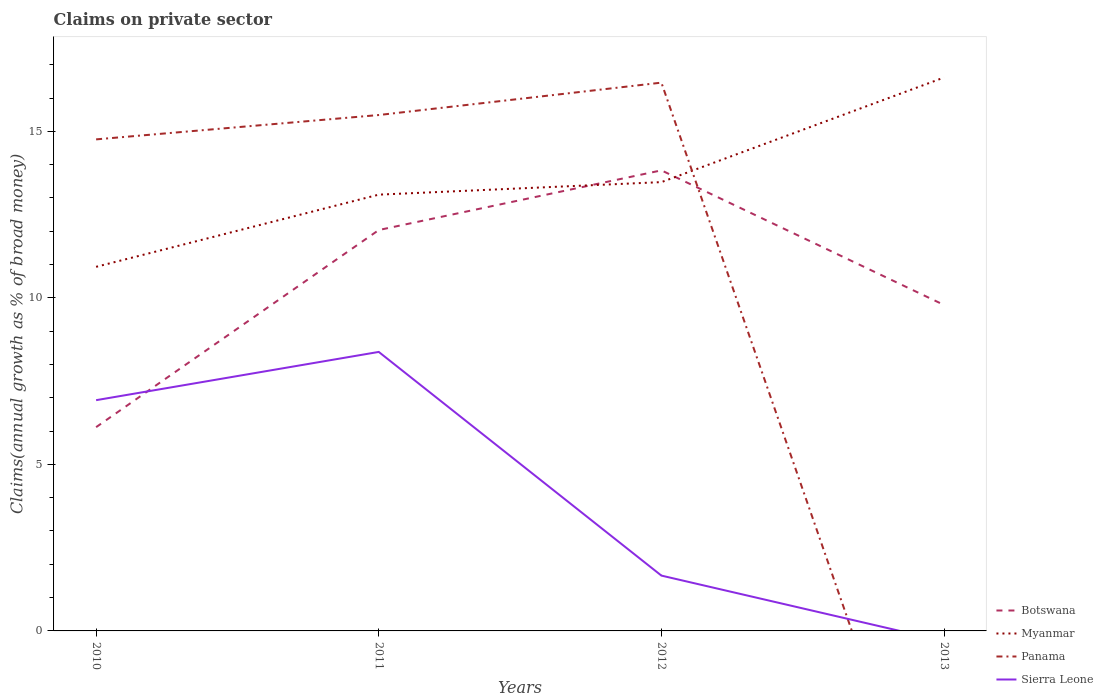How many different coloured lines are there?
Your answer should be compact. 4. Across all years, what is the maximum percentage of broad money claimed on private sector in Sierra Leone?
Provide a short and direct response. 0. What is the total percentage of broad money claimed on private sector in Botswana in the graph?
Provide a succinct answer. 4.04. What is the difference between the highest and the second highest percentage of broad money claimed on private sector in Sierra Leone?
Your answer should be compact. 8.38. Are the values on the major ticks of Y-axis written in scientific E-notation?
Your response must be concise. No. Where does the legend appear in the graph?
Give a very brief answer. Bottom right. How many legend labels are there?
Your answer should be very brief. 4. How are the legend labels stacked?
Offer a terse response. Vertical. What is the title of the graph?
Offer a terse response. Claims on private sector. What is the label or title of the X-axis?
Provide a short and direct response. Years. What is the label or title of the Y-axis?
Your response must be concise. Claims(annual growth as % of broad money). What is the Claims(annual growth as % of broad money) of Botswana in 2010?
Offer a very short reply. 6.12. What is the Claims(annual growth as % of broad money) of Myanmar in 2010?
Make the answer very short. 10.93. What is the Claims(annual growth as % of broad money) in Panama in 2010?
Your answer should be very brief. 14.76. What is the Claims(annual growth as % of broad money) of Sierra Leone in 2010?
Provide a succinct answer. 6.93. What is the Claims(annual growth as % of broad money) in Botswana in 2011?
Give a very brief answer. 12.04. What is the Claims(annual growth as % of broad money) in Myanmar in 2011?
Offer a very short reply. 13.1. What is the Claims(annual growth as % of broad money) in Panama in 2011?
Give a very brief answer. 15.49. What is the Claims(annual growth as % of broad money) in Sierra Leone in 2011?
Offer a very short reply. 8.38. What is the Claims(annual growth as % of broad money) of Botswana in 2012?
Your answer should be compact. 13.83. What is the Claims(annual growth as % of broad money) of Myanmar in 2012?
Provide a succinct answer. 13.47. What is the Claims(annual growth as % of broad money) in Panama in 2012?
Offer a very short reply. 16.46. What is the Claims(annual growth as % of broad money) of Sierra Leone in 2012?
Offer a very short reply. 1.66. What is the Claims(annual growth as % of broad money) in Botswana in 2013?
Make the answer very short. 9.79. What is the Claims(annual growth as % of broad money) in Myanmar in 2013?
Offer a terse response. 16.62. What is the Claims(annual growth as % of broad money) in Panama in 2013?
Provide a succinct answer. 0. What is the Claims(annual growth as % of broad money) in Sierra Leone in 2013?
Your answer should be very brief. 0. Across all years, what is the maximum Claims(annual growth as % of broad money) of Botswana?
Ensure brevity in your answer.  13.83. Across all years, what is the maximum Claims(annual growth as % of broad money) in Myanmar?
Provide a short and direct response. 16.62. Across all years, what is the maximum Claims(annual growth as % of broad money) of Panama?
Offer a very short reply. 16.46. Across all years, what is the maximum Claims(annual growth as % of broad money) in Sierra Leone?
Offer a very short reply. 8.38. Across all years, what is the minimum Claims(annual growth as % of broad money) of Botswana?
Your answer should be very brief. 6.12. Across all years, what is the minimum Claims(annual growth as % of broad money) in Myanmar?
Your answer should be very brief. 10.93. Across all years, what is the minimum Claims(annual growth as % of broad money) of Sierra Leone?
Your answer should be very brief. 0. What is the total Claims(annual growth as % of broad money) of Botswana in the graph?
Your response must be concise. 41.77. What is the total Claims(annual growth as % of broad money) in Myanmar in the graph?
Give a very brief answer. 54.12. What is the total Claims(annual growth as % of broad money) of Panama in the graph?
Your answer should be very brief. 46.71. What is the total Claims(annual growth as % of broad money) of Sierra Leone in the graph?
Your response must be concise. 16.97. What is the difference between the Claims(annual growth as % of broad money) of Botswana in 2010 and that in 2011?
Your response must be concise. -5.92. What is the difference between the Claims(annual growth as % of broad money) in Myanmar in 2010 and that in 2011?
Offer a very short reply. -2.17. What is the difference between the Claims(annual growth as % of broad money) of Panama in 2010 and that in 2011?
Offer a terse response. -0.73. What is the difference between the Claims(annual growth as % of broad money) in Sierra Leone in 2010 and that in 2011?
Give a very brief answer. -1.45. What is the difference between the Claims(annual growth as % of broad money) in Botswana in 2010 and that in 2012?
Your response must be concise. -7.71. What is the difference between the Claims(annual growth as % of broad money) of Myanmar in 2010 and that in 2012?
Offer a terse response. -2.54. What is the difference between the Claims(annual growth as % of broad money) of Panama in 2010 and that in 2012?
Keep it short and to the point. -1.7. What is the difference between the Claims(annual growth as % of broad money) of Sierra Leone in 2010 and that in 2012?
Give a very brief answer. 5.27. What is the difference between the Claims(annual growth as % of broad money) in Botswana in 2010 and that in 2013?
Offer a very short reply. -3.67. What is the difference between the Claims(annual growth as % of broad money) of Myanmar in 2010 and that in 2013?
Provide a short and direct response. -5.68. What is the difference between the Claims(annual growth as % of broad money) in Botswana in 2011 and that in 2012?
Give a very brief answer. -1.79. What is the difference between the Claims(annual growth as % of broad money) of Myanmar in 2011 and that in 2012?
Keep it short and to the point. -0.38. What is the difference between the Claims(annual growth as % of broad money) in Panama in 2011 and that in 2012?
Give a very brief answer. -0.97. What is the difference between the Claims(annual growth as % of broad money) in Sierra Leone in 2011 and that in 2012?
Ensure brevity in your answer.  6.72. What is the difference between the Claims(annual growth as % of broad money) of Botswana in 2011 and that in 2013?
Make the answer very short. 2.25. What is the difference between the Claims(annual growth as % of broad money) in Myanmar in 2011 and that in 2013?
Your answer should be very brief. -3.52. What is the difference between the Claims(annual growth as % of broad money) of Botswana in 2012 and that in 2013?
Give a very brief answer. 4.04. What is the difference between the Claims(annual growth as % of broad money) of Myanmar in 2012 and that in 2013?
Give a very brief answer. -3.14. What is the difference between the Claims(annual growth as % of broad money) in Botswana in 2010 and the Claims(annual growth as % of broad money) in Myanmar in 2011?
Offer a terse response. -6.98. What is the difference between the Claims(annual growth as % of broad money) of Botswana in 2010 and the Claims(annual growth as % of broad money) of Panama in 2011?
Provide a succinct answer. -9.37. What is the difference between the Claims(annual growth as % of broad money) in Botswana in 2010 and the Claims(annual growth as % of broad money) in Sierra Leone in 2011?
Offer a very short reply. -2.26. What is the difference between the Claims(annual growth as % of broad money) of Myanmar in 2010 and the Claims(annual growth as % of broad money) of Panama in 2011?
Offer a terse response. -4.56. What is the difference between the Claims(annual growth as % of broad money) of Myanmar in 2010 and the Claims(annual growth as % of broad money) of Sierra Leone in 2011?
Your answer should be compact. 2.56. What is the difference between the Claims(annual growth as % of broad money) in Panama in 2010 and the Claims(annual growth as % of broad money) in Sierra Leone in 2011?
Give a very brief answer. 6.38. What is the difference between the Claims(annual growth as % of broad money) in Botswana in 2010 and the Claims(annual growth as % of broad money) in Myanmar in 2012?
Make the answer very short. -7.36. What is the difference between the Claims(annual growth as % of broad money) in Botswana in 2010 and the Claims(annual growth as % of broad money) in Panama in 2012?
Make the answer very short. -10.34. What is the difference between the Claims(annual growth as % of broad money) of Botswana in 2010 and the Claims(annual growth as % of broad money) of Sierra Leone in 2012?
Make the answer very short. 4.46. What is the difference between the Claims(annual growth as % of broad money) of Myanmar in 2010 and the Claims(annual growth as % of broad money) of Panama in 2012?
Your answer should be very brief. -5.53. What is the difference between the Claims(annual growth as % of broad money) of Myanmar in 2010 and the Claims(annual growth as % of broad money) of Sierra Leone in 2012?
Your response must be concise. 9.27. What is the difference between the Claims(annual growth as % of broad money) of Panama in 2010 and the Claims(annual growth as % of broad money) of Sierra Leone in 2012?
Offer a terse response. 13.1. What is the difference between the Claims(annual growth as % of broad money) of Botswana in 2010 and the Claims(annual growth as % of broad money) of Myanmar in 2013?
Ensure brevity in your answer.  -10.5. What is the difference between the Claims(annual growth as % of broad money) of Botswana in 2011 and the Claims(annual growth as % of broad money) of Myanmar in 2012?
Make the answer very short. -1.44. What is the difference between the Claims(annual growth as % of broad money) of Botswana in 2011 and the Claims(annual growth as % of broad money) of Panama in 2012?
Give a very brief answer. -4.43. What is the difference between the Claims(annual growth as % of broad money) in Botswana in 2011 and the Claims(annual growth as % of broad money) in Sierra Leone in 2012?
Make the answer very short. 10.37. What is the difference between the Claims(annual growth as % of broad money) in Myanmar in 2011 and the Claims(annual growth as % of broad money) in Panama in 2012?
Your answer should be compact. -3.36. What is the difference between the Claims(annual growth as % of broad money) in Myanmar in 2011 and the Claims(annual growth as % of broad money) in Sierra Leone in 2012?
Provide a succinct answer. 11.44. What is the difference between the Claims(annual growth as % of broad money) in Panama in 2011 and the Claims(annual growth as % of broad money) in Sierra Leone in 2012?
Offer a very short reply. 13.83. What is the difference between the Claims(annual growth as % of broad money) in Botswana in 2011 and the Claims(annual growth as % of broad money) in Myanmar in 2013?
Keep it short and to the point. -4.58. What is the difference between the Claims(annual growth as % of broad money) in Botswana in 2012 and the Claims(annual growth as % of broad money) in Myanmar in 2013?
Make the answer very short. -2.79. What is the average Claims(annual growth as % of broad money) of Botswana per year?
Your response must be concise. 10.44. What is the average Claims(annual growth as % of broad money) of Myanmar per year?
Your answer should be very brief. 13.53. What is the average Claims(annual growth as % of broad money) of Panama per year?
Your answer should be very brief. 11.68. What is the average Claims(annual growth as % of broad money) in Sierra Leone per year?
Give a very brief answer. 4.24. In the year 2010, what is the difference between the Claims(annual growth as % of broad money) in Botswana and Claims(annual growth as % of broad money) in Myanmar?
Give a very brief answer. -4.81. In the year 2010, what is the difference between the Claims(annual growth as % of broad money) of Botswana and Claims(annual growth as % of broad money) of Panama?
Give a very brief answer. -8.64. In the year 2010, what is the difference between the Claims(annual growth as % of broad money) of Botswana and Claims(annual growth as % of broad money) of Sierra Leone?
Offer a very short reply. -0.81. In the year 2010, what is the difference between the Claims(annual growth as % of broad money) of Myanmar and Claims(annual growth as % of broad money) of Panama?
Provide a short and direct response. -3.83. In the year 2010, what is the difference between the Claims(annual growth as % of broad money) of Myanmar and Claims(annual growth as % of broad money) of Sierra Leone?
Offer a terse response. 4. In the year 2010, what is the difference between the Claims(annual growth as % of broad money) of Panama and Claims(annual growth as % of broad money) of Sierra Leone?
Ensure brevity in your answer.  7.83. In the year 2011, what is the difference between the Claims(annual growth as % of broad money) in Botswana and Claims(annual growth as % of broad money) in Myanmar?
Your answer should be very brief. -1.06. In the year 2011, what is the difference between the Claims(annual growth as % of broad money) in Botswana and Claims(annual growth as % of broad money) in Panama?
Your answer should be compact. -3.45. In the year 2011, what is the difference between the Claims(annual growth as % of broad money) in Botswana and Claims(annual growth as % of broad money) in Sierra Leone?
Ensure brevity in your answer.  3.66. In the year 2011, what is the difference between the Claims(annual growth as % of broad money) of Myanmar and Claims(annual growth as % of broad money) of Panama?
Your response must be concise. -2.39. In the year 2011, what is the difference between the Claims(annual growth as % of broad money) in Myanmar and Claims(annual growth as % of broad money) in Sierra Leone?
Make the answer very short. 4.72. In the year 2011, what is the difference between the Claims(annual growth as % of broad money) of Panama and Claims(annual growth as % of broad money) of Sierra Leone?
Offer a very short reply. 7.11. In the year 2012, what is the difference between the Claims(annual growth as % of broad money) in Botswana and Claims(annual growth as % of broad money) in Myanmar?
Keep it short and to the point. 0.35. In the year 2012, what is the difference between the Claims(annual growth as % of broad money) of Botswana and Claims(annual growth as % of broad money) of Panama?
Make the answer very short. -2.63. In the year 2012, what is the difference between the Claims(annual growth as % of broad money) of Botswana and Claims(annual growth as % of broad money) of Sierra Leone?
Ensure brevity in your answer.  12.17. In the year 2012, what is the difference between the Claims(annual growth as % of broad money) of Myanmar and Claims(annual growth as % of broad money) of Panama?
Provide a short and direct response. -2.99. In the year 2012, what is the difference between the Claims(annual growth as % of broad money) in Myanmar and Claims(annual growth as % of broad money) in Sierra Leone?
Make the answer very short. 11.81. In the year 2012, what is the difference between the Claims(annual growth as % of broad money) of Panama and Claims(annual growth as % of broad money) of Sierra Leone?
Offer a terse response. 14.8. In the year 2013, what is the difference between the Claims(annual growth as % of broad money) of Botswana and Claims(annual growth as % of broad money) of Myanmar?
Offer a very short reply. -6.83. What is the ratio of the Claims(annual growth as % of broad money) of Botswana in 2010 to that in 2011?
Offer a terse response. 0.51. What is the ratio of the Claims(annual growth as % of broad money) in Myanmar in 2010 to that in 2011?
Offer a terse response. 0.83. What is the ratio of the Claims(annual growth as % of broad money) of Panama in 2010 to that in 2011?
Keep it short and to the point. 0.95. What is the ratio of the Claims(annual growth as % of broad money) in Sierra Leone in 2010 to that in 2011?
Provide a succinct answer. 0.83. What is the ratio of the Claims(annual growth as % of broad money) of Botswana in 2010 to that in 2012?
Your answer should be compact. 0.44. What is the ratio of the Claims(annual growth as % of broad money) of Myanmar in 2010 to that in 2012?
Give a very brief answer. 0.81. What is the ratio of the Claims(annual growth as % of broad money) of Panama in 2010 to that in 2012?
Your answer should be very brief. 0.9. What is the ratio of the Claims(annual growth as % of broad money) of Sierra Leone in 2010 to that in 2012?
Offer a terse response. 4.17. What is the ratio of the Claims(annual growth as % of broad money) in Botswana in 2010 to that in 2013?
Offer a very short reply. 0.63. What is the ratio of the Claims(annual growth as % of broad money) of Myanmar in 2010 to that in 2013?
Offer a very short reply. 0.66. What is the ratio of the Claims(annual growth as % of broad money) in Botswana in 2011 to that in 2012?
Offer a terse response. 0.87. What is the ratio of the Claims(annual growth as % of broad money) in Myanmar in 2011 to that in 2012?
Offer a very short reply. 0.97. What is the ratio of the Claims(annual growth as % of broad money) in Panama in 2011 to that in 2012?
Provide a succinct answer. 0.94. What is the ratio of the Claims(annual growth as % of broad money) in Sierra Leone in 2011 to that in 2012?
Make the answer very short. 5.04. What is the ratio of the Claims(annual growth as % of broad money) of Botswana in 2011 to that in 2013?
Your response must be concise. 1.23. What is the ratio of the Claims(annual growth as % of broad money) in Myanmar in 2011 to that in 2013?
Your response must be concise. 0.79. What is the ratio of the Claims(annual growth as % of broad money) in Botswana in 2012 to that in 2013?
Your answer should be compact. 1.41. What is the ratio of the Claims(annual growth as % of broad money) in Myanmar in 2012 to that in 2013?
Offer a very short reply. 0.81. What is the difference between the highest and the second highest Claims(annual growth as % of broad money) in Botswana?
Give a very brief answer. 1.79. What is the difference between the highest and the second highest Claims(annual growth as % of broad money) of Myanmar?
Your answer should be very brief. 3.14. What is the difference between the highest and the second highest Claims(annual growth as % of broad money) of Panama?
Offer a very short reply. 0.97. What is the difference between the highest and the second highest Claims(annual growth as % of broad money) in Sierra Leone?
Your answer should be compact. 1.45. What is the difference between the highest and the lowest Claims(annual growth as % of broad money) in Botswana?
Ensure brevity in your answer.  7.71. What is the difference between the highest and the lowest Claims(annual growth as % of broad money) in Myanmar?
Your answer should be compact. 5.68. What is the difference between the highest and the lowest Claims(annual growth as % of broad money) in Panama?
Offer a terse response. 16.46. What is the difference between the highest and the lowest Claims(annual growth as % of broad money) of Sierra Leone?
Provide a short and direct response. 8.38. 